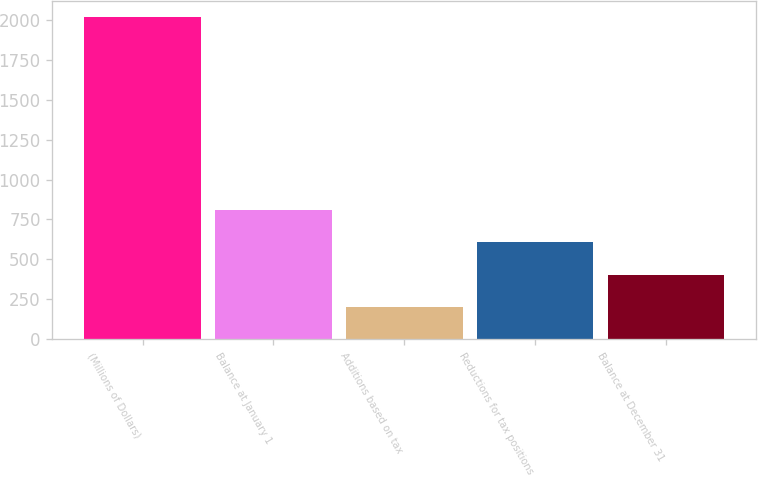<chart> <loc_0><loc_0><loc_500><loc_500><bar_chart><fcel>(Millions of Dollars)<fcel>Balance at January 1<fcel>Additions based on tax<fcel>Reductions for tax positions<fcel>Balance at December 31<nl><fcel>2017<fcel>807.4<fcel>202.6<fcel>605.8<fcel>404.2<nl></chart> 